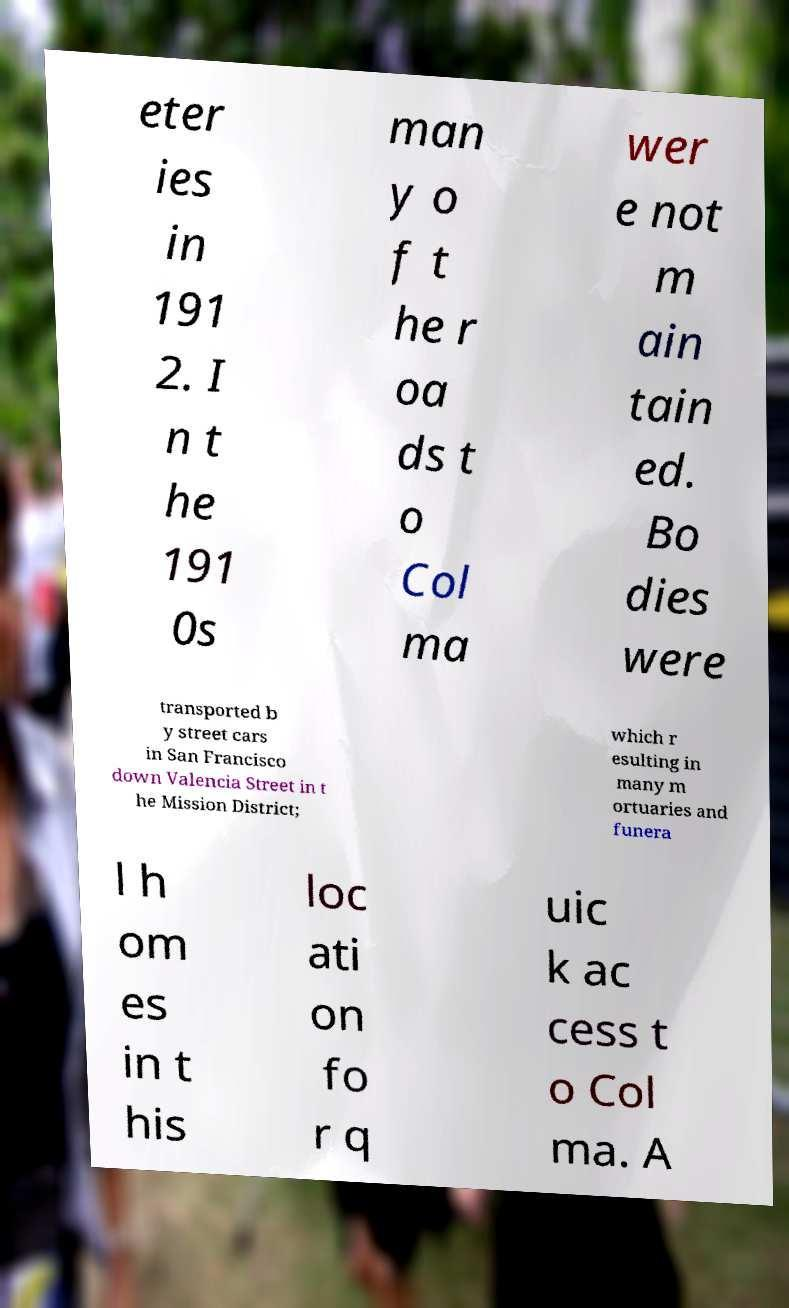For documentation purposes, I need the text within this image transcribed. Could you provide that? eter ies in 191 2. I n t he 191 0s man y o f t he r oa ds t o Col ma wer e not m ain tain ed. Bo dies were transported b y street cars in San Francisco down Valencia Street in t he Mission District; which r esulting in many m ortuaries and funera l h om es in t his loc ati on fo r q uic k ac cess t o Col ma. A 